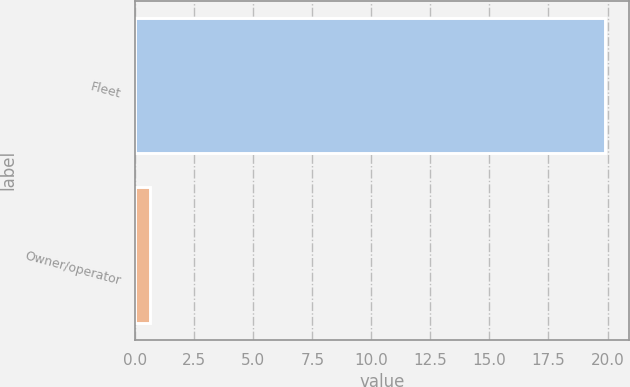Convert chart. <chart><loc_0><loc_0><loc_500><loc_500><bar_chart><fcel>Fleet<fcel>Owner/operator<nl><fcel>19.9<fcel>0.6<nl></chart> 